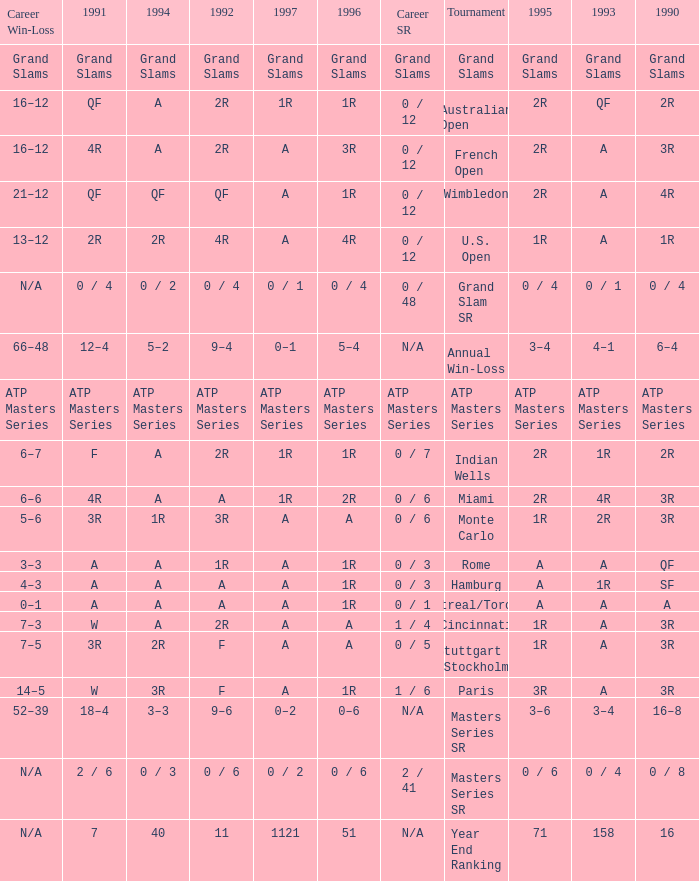What is 1994, when 1991 is "QF", and when Tournament is "Australian Open"? A. 